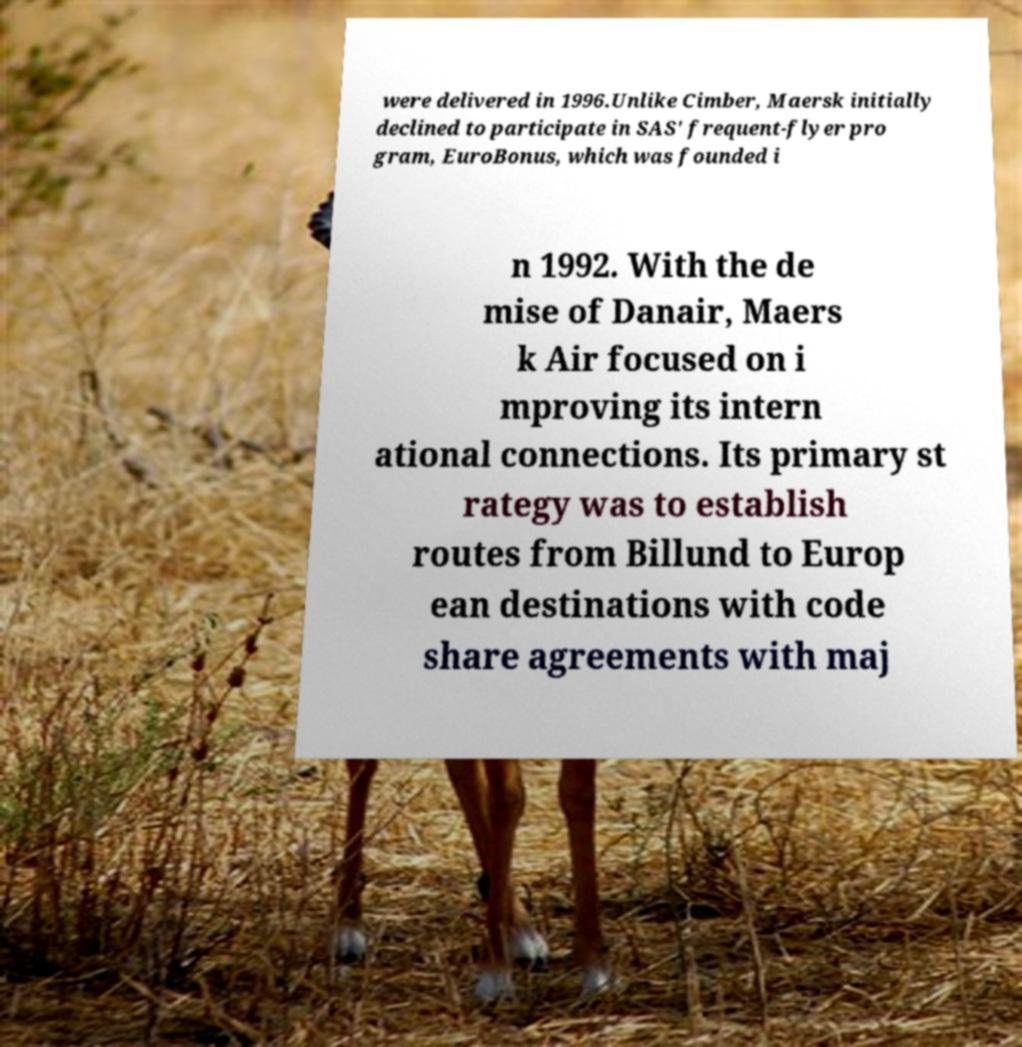Please read and relay the text visible in this image. What does it say? were delivered in 1996.Unlike Cimber, Maersk initially declined to participate in SAS' frequent-flyer pro gram, EuroBonus, which was founded i n 1992. With the de mise of Danair, Maers k Air focused on i mproving its intern ational connections. Its primary st rategy was to establish routes from Billund to Europ ean destinations with code share agreements with maj 